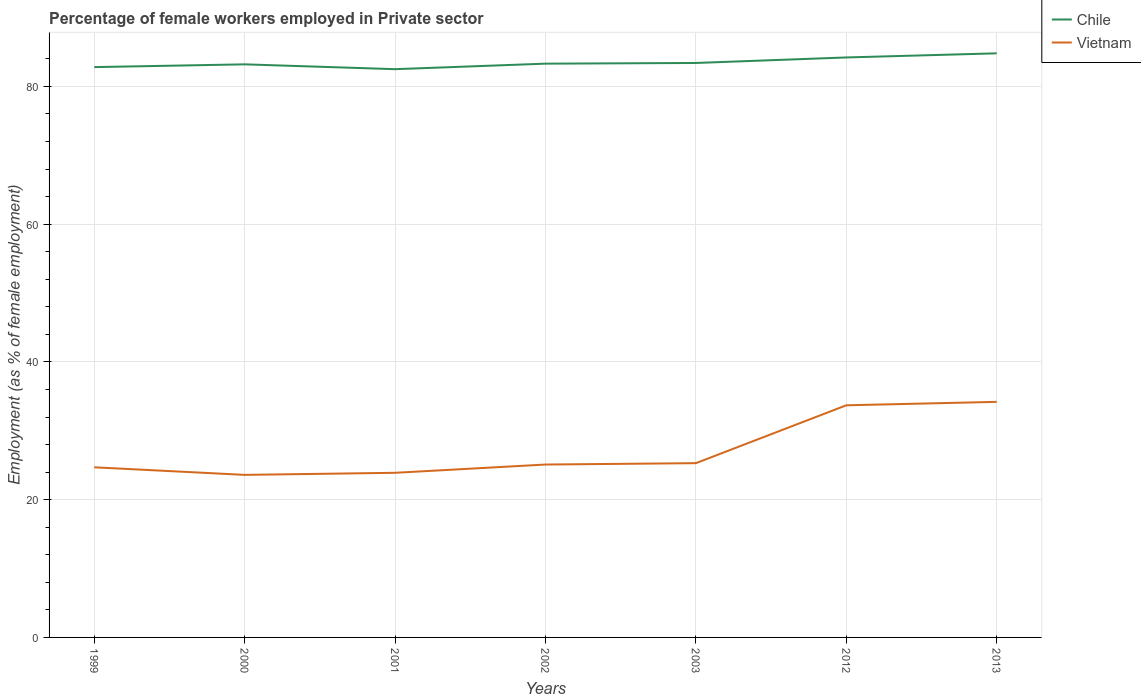How many different coloured lines are there?
Give a very brief answer. 2. Does the line corresponding to Chile intersect with the line corresponding to Vietnam?
Your response must be concise. No. Is the number of lines equal to the number of legend labels?
Give a very brief answer. Yes. Across all years, what is the maximum percentage of females employed in Private sector in Chile?
Provide a short and direct response. 82.5. In which year was the percentage of females employed in Private sector in Vietnam maximum?
Provide a succinct answer. 2000. What is the total percentage of females employed in Private sector in Vietnam in the graph?
Your response must be concise. -10.6. What is the difference between the highest and the second highest percentage of females employed in Private sector in Chile?
Ensure brevity in your answer.  2.3. What is the difference between the highest and the lowest percentage of females employed in Private sector in Chile?
Provide a short and direct response. 2. How many lines are there?
Give a very brief answer. 2. What is the difference between two consecutive major ticks on the Y-axis?
Ensure brevity in your answer.  20. Does the graph contain any zero values?
Your answer should be compact. No. Where does the legend appear in the graph?
Make the answer very short. Top right. What is the title of the graph?
Make the answer very short. Percentage of female workers employed in Private sector. Does "Algeria" appear as one of the legend labels in the graph?
Give a very brief answer. No. What is the label or title of the Y-axis?
Make the answer very short. Employment (as % of female employment). What is the Employment (as % of female employment) of Chile in 1999?
Make the answer very short. 82.8. What is the Employment (as % of female employment) of Vietnam in 1999?
Give a very brief answer. 24.7. What is the Employment (as % of female employment) in Chile in 2000?
Your response must be concise. 83.2. What is the Employment (as % of female employment) of Vietnam in 2000?
Provide a succinct answer. 23.6. What is the Employment (as % of female employment) in Chile in 2001?
Ensure brevity in your answer.  82.5. What is the Employment (as % of female employment) in Vietnam in 2001?
Ensure brevity in your answer.  23.9. What is the Employment (as % of female employment) of Chile in 2002?
Ensure brevity in your answer.  83.3. What is the Employment (as % of female employment) in Vietnam in 2002?
Offer a very short reply. 25.1. What is the Employment (as % of female employment) in Chile in 2003?
Offer a terse response. 83.4. What is the Employment (as % of female employment) of Vietnam in 2003?
Offer a terse response. 25.3. What is the Employment (as % of female employment) in Chile in 2012?
Your answer should be compact. 84.2. What is the Employment (as % of female employment) in Vietnam in 2012?
Your response must be concise. 33.7. What is the Employment (as % of female employment) in Chile in 2013?
Your response must be concise. 84.8. What is the Employment (as % of female employment) in Vietnam in 2013?
Provide a short and direct response. 34.2. Across all years, what is the maximum Employment (as % of female employment) in Chile?
Your answer should be very brief. 84.8. Across all years, what is the maximum Employment (as % of female employment) of Vietnam?
Offer a terse response. 34.2. Across all years, what is the minimum Employment (as % of female employment) in Chile?
Provide a short and direct response. 82.5. Across all years, what is the minimum Employment (as % of female employment) in Vietnam?
Give a very brief answer. 23.6. What is the total Employment (as % of female employment) of Chile in the graph?
Your answer should be compact. 584.2. What is the total Employment (as % of female employment) in Vietnam in the graph?
Your answer should be compact. 190.5. What is the difference between the Employment (as % of female employment) of Chile in 1999 and that in 2000?
Offer a very short reply. -0.4. What is the difference between the Employment (as % of female employment) in Chile in 1999 and that in 2001?
Give a very brief answer. 0.3. What is the difference between the Employment (as % of female employment) in Vietnam in 1999 and that in 2002?
Provide a short and direct response. -0.4. What is the difference between the Employment (as % of female employment) in Chile in 1999 and that in 2003?
Provide a succinct answer. -0.6. What is the difference between the Employment (as % of female employment) in Vietnam in 1999 and that in 2003?
Your response must be concise. -0.6. What is the difference between the Employment (as % of female employment) of Chile in 1999 and that in 2012?
Give a very brief answer. -1.4. What is the difference between the Employment (as % of female employment) in Vietnam in 1999 and that in 2012?
Make the answer very short. -9. What is the difference between the Employment (as % of female employment) of Chile in 1999 and that in 2013?
Your answer should be very brief. -2. What is the difference between the Employment (as % of female employment) of Vietnam in 1999 and that in 2013?
Offer a very short reply. -9.5. What is the difference between the Employment (as % of female employment) in Vietnam in 2000 and that in 2002?
Provide a short and direct response. -1.5. What is the difference between the Employment (as % of female employment) in Chile in 2000 and that in 2003?
Your response must be concise. -0.2. What is the difference between the Employment (as % of female employment) in Chile in 2000 and that in 2013?
Your response must be concise. -1.6. What is the difference between the Employment (as % of female employment) of Vietnam in 2000 and that in 2013?
Keep it short and to the point. -10.6. What is the difference between the Employment (as % of female employment) of Vietnam in 2001 and that in 2002?
Make the answer very short. -1.2. What is the difference between the Employment (as % of female employment) in Vietnam in 2001 and that in 2003?
Your response must be concise. -1.4. What is the difference between the Employment (as % of female employment) of Chile in 2001 and that in 2013?
Your answer should be very brief. -2.3. What is the difference between the Employment (as % of female employment) of Vietnam in 2001 and that in 2013?
Your response must be concise. -10.3. What is the difference between the Employment (as % of female employment) of Vietnam in 2002 and that in 2003?
Give a very brief answer. -0.2. What is the difference between the Employment (as % of female employment) in Vietnam in 2002 and that in 2012?
Keep it short and to the point. -8.6. What is the difference between the Employment (as % of female employment) in Chile in 2002 and that in 2013?
Your answer should be very brief. -1.5. What is the difference between the Employment (as % of female employment) of Vietnam in 2003 and that in 2012?
Ensure brevity in your answer.  -8.4. What is the difference between the Employment (as % of female employment) of Chile in 2003 and that in 2013?
Make the answer very short. -1.4. What is the difference between the Employment (as % of female employment) of Vietnam in 2003 and that in 2013?
Give a very brief answer. -8.9. What is the difference between the Employment (as % of female employment) in Chile in 2012 and that in 2013?
Keep it short and to the point. -0.6. What is the difference between the Employment (as % of female employment) in Chile in 1999 and the Employment (as % of female employment) in Vietnam in 2000?
Your answer should be very brief. 59.2. What is the difference between the Employment (as % of female employment) of Chile in 1999 and the Employment (as % of female employment) of Vietnam in 2001?
Provide a succinct answer. 58.9. What is the difference between the Employment (as % of female employment) of Chile in 1999 and the Employment (as % of female employment) of Vietnam in 2002?
Your response must be concise. 57.7. What is the difference between the Employment (as % of female employment) in Chile in 1999 and the Employment (as % of female employment) in Vietnam in 2003?
Your response must be concise. 57.5. What is the difference between the Employment (as % of female employment) of Chile in 1999 and the Employment (as % of female employment) of Vietnam in 2012?
Offer a terse response. 49.1. What is the difference between the Employment (as % of female employment) in Chile in 1999 and the Employment (as % of female employment) in Vietnam in 2013?
Keep it short and to the point. 48.6. What is the difference between the Employment (as % of female employment) of Chile in 2000 and the Employment (as % of female employment) of Vietnam in 2001?
Give a very brief answer. 59.3. What is the difference between the Employment (as % of female employment) in Chile in 2000 and the Employment (as % of female employment) in Vietnam in 2002?
Your answer should be compact. 58.1. What is the difference between the Employment (as % of female employment) in Chile in 2000 and the Employment (as % of female employment) in Vietnam in 2003?
Provide a succinct answer. 57.9. What is the difference between the Employment (as % of female employment) in Chile in 2000 and the Employment (as % of female employment) in Vietnam in 2012?
Provide a short and direct response. 49.5. What is the difference between the Employment (as % of female employment) of Chile in 2000 and the Employment (as % of female employment) of Vietnam in 2013?
Provide a succinct answer. 49. What is the difference between the Employment (as % of female employment) in Chile in 2001 and the Employment (as % of female employment) in Vietnam in 2002?
Your answer should be very brief. 57.4. What is the difference between the Employment (as % of female employment) of Chile in 2001 and the Employment (as % of female employment) of Vietnam in 2003?
Offer a terse response. 57.2. What is the difference between the Employment (as % of female employment) in Chile in 2001 and the Employment (as % of female employment) in Vietnam in 2012?
Ensure brevity in your answer.  48.8. What is the difference between the Employment (as % of female employment) of Chile in 2001 and the Employment (as % of female employment) of Vietnam in 2013?
Provide a succinct answer. 48.3. What is the difference between the Employment (as % of female employment) in Chile in 2002 and the Employment (as % of female employment) in Vietnam in 2003?
Your answer should be very brief. 58. What is the difference between the Employment (as % of female employment) of Chile in 2002 and the Employment (as % of female employment) of Vietnam in 2012?
Keep it short and to the point. 49.6. What is the difference between the Employment (as % of female employment) in Chile in 2002 and the Employment (as % of female employment) in Vietnam in 2013?
Your answer should be compact. 49.1. What is the difference between the Employment (as % of female employment) of Chile in 2003 and the Employment (as % of female employment) of Vietnam in 2012?
Your response must be concise. 49.7. What is the difference between the Employment (as % of female employment) in Chile in 2003 and the Employment (as % of female employment) in Vietnam in 2013?
Offer a terse response. 49.2. What is the average Employment (as % of female employment) in Chile per year?
Ensure brevity in your answer.  83.46. What is the average Employment (as % of female employment) of Vietnam per year?
Give a very brief answer. 27.21. In the year 1999, what is the difference between the Employment (as % of female employment) of Chile and Employment (as % of female employment) of Vietnam?
Give a very brief answer. 58.1. In the year 2000, what is the difference between the Employment (as % of female employment) of Chile and Employment (as % of female employment) of Vietnam?
Provide a succinct answer. 59.6. In the year 2001, what is the difference between the Employment (as % of female employment) of Chile and Employment (as % of female employment) of Vietnam?
Make the answer very short. 58.6. In the year 2002, what is the difference between the Employment (as % of female employment) in Chile and Employment (as % of female employment) in Vietnam?
Offer a very short reply. 58.2. In the year 2003, what is the difference between the Employment (as % of female employment) in Chile and Employment (as % of female employment) in Vietnam?
Offer a terse response. 58.1. In the year 2012, what is the difference between the Employment (as % of female employment) of Chile and Employment (as % of female employment) of Vietnam?
Your answer should be very brief. 50.5. In the year 2013, what is the difference between the Employment (as % of female employment) of Chile and Employment (as % of female employment) of Vietnam?
Ensure brevity in your answer.  50.6. What is the ratio of the Employment (as % of female employment) in Vietnam in 1999 to that in 2000?
Keep it short and to the point. 1.05. What is the ratio of the Employment (as % of female employment) of Vietnam in 1999 to that in 2001?
Give a very brief answer. 1.03. What is the ratio of the Employment (as % of female employment) of Chile in 1999 to that in 2002?
Provide a succinct answer. 0.99. What is the ratio of the Employment (as % of female employment) in Vietnam in 1999 to that in 2002?
Provide a short and direct response. 0.98. What is the ratio of the Employment (as % of female employment) of Vietnam in 1999 to that in 2003?
Give a very brief answer. 0.98. What is the ratio of the Employment (as % of female employment) of Chile in 1999 to that in 2012?
Your answer should be compact. 0.98. What is the ratio of the Employment (as % of female employment) in Vietnam in 1999 to that in 2012?
Your answer should be compact. 0.73. What is the ratio of the Employment (as % of female employment) in Chile in 1999 to that in 2013?
Make the answer very short. 0.98. What is the ratio of the Employment (as % of female employment) in Vietnam in 1999 to that in 2013?
Your response must be concise. 0.72. What is the ratio of the Employment (as % of female employment) of Chile in 2000 to that in 2001?
Your response must be concise. 1.01. What is the ratio of the Employment (as % of female employment) in Vietnam in 2000 to that in 2001?
Offer a very short reply. 0.99. What is the ratio of the Employment (as % of female employment) in Chile in 2000 to that in 2002?
Your response must be concise. 1. What is the ratio of the Employment (as % of female employment) in Vietnam in 2000 to that in 2002?
Offer a terse response. 0.94. What is the ratio of the Employment (as % of female employment) in Vietnam in 2000 to that in 2003?
Offer a very short reply. 0.93. What is the ratio of the Employment (as % of female employment) in Chile in 2000 to that in 2012?
Provide a short and direct response. 0.99. What is the ratio of the Employment (as % of female employment) of Vietnam in 2000 to that in 2012?
Provide a succinct answer. 0.7. What is the ratio of the Employment (as % of female employment) in Chile in 2000 to that in 2013?
Offer a very short reply. 0.98. What is the ratio of the Employment (as % of female employment) in Vietnam in 2000 to that in 2013?
Provide a short and direct response. 0.69. What is the ratio of the Employment (as % of female employment) of Chile in 2001 to that in 2002?
Make the answer very short. 0.99. What is the ratio of the Employment (as % of female employment) in Vietnam in 2001 to that in 2002?
Keep it short and to the point. 0.95. What is the ratio of the Employment (as % of female employment) in Chile in 2001 to that in 2003?
Make the answer very short. 0.99. What is the ratio of the Employment (as % of female employment) in Vietnam in 2001 to that in 2003?
Ensure brevity in your answer.  0.94. What is the ratio of the Employment (as % of female employment) of Chile in 2001 to that in 2012?
Your answer should be very brief. 0.98. What is the ratio of the Employment (as % of female employment) in Vietnam in 2001 to that in 2012?
Keep it short and to the point. 0.71. What is the ratio of the Employment (as % of female employment) in Chile in 2001 to that in 2013?
Your response must be concise. 0.97. What is the ratio of the Employment (as % of female employment) in Vietnam in 2001 to that in 2013?
Provide a short and direct response. 0.7. What is the ratio of the Employment (as % of female employment) of Chile in 2002 to that in 2012?
Ensure brevity in your answer.  0.99. What is the ratio of the Employment (as % of female employment) in Vietnam in 2002 to that in 2012?
Your response must be concise. 0.74. What is the ratio of the Employment (as % of female employment) of Chile in 2002 to that in 2013?
Provide a succinct answer. 0.98. What is the ratio of the Employment (as % of female employment) of Vietnam in 2002 to that in 2013?
Ensure brevity in your answer.  0.73. What is the ratio of the Employment (as % of female employment) of Chile in 2003 to that in 2012?
Make the answer very short. 0.99. What is the ratio of the Employment (as % of female employment) of Vietnam in 2003 to that in 2012?
Give a very brief answer. 0.75. What is the ratio of the Employment (as % of female employment) of Chile in 2003 to that in 2013?
Your answer should be very brief. 0.98. What is the ratio of the Employment (as % of female employment) of Vietnam in 2003 to that in 2013?
Provide a short and direct response. 0.74. What is the ratio of the Employment (as % of female employment) in Chile in 2012 to that in 2013?
Give a very brief answer. 0.99. What is the ratio of the Employment (as % of female employment) of Vietnam in 2012 to that in 2013?
Make the answer very short. 0.99. What is the difference between the highest and the lowest Employment (as % of female employment) of Chile?
Your answer should be compact. 2.3. What is the difference between the highest and the lowest Employment (as % of female employment) of Vietnam?
Ensure brevity in your answer.  10.6. 